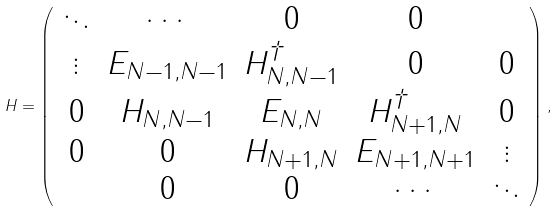Convert formula to latex. <formula><loc_0><loc_0><loc_500><loc_500>H = \left ( \begin{array} { c c c c c } \ddots & \cdots & 0 & 0 & \\ \vdots & E _ { N - 1 , N - 1 } & H _ { N , N - 1 } ^ { \dagger } & 0 & 0 \\ 0 & H _ { N , N - 1 } & E _ { N , N } & H _ { N + 1 , N } ^ { \dagger } & 0 \\ 0 & 0 & H _ { N + 1 , N } & E _ { N + 1 , N + 1 } & \vdots \\ & 0 & 0 & \cdots & \ddots \end{array} \right ) ,</formula> 